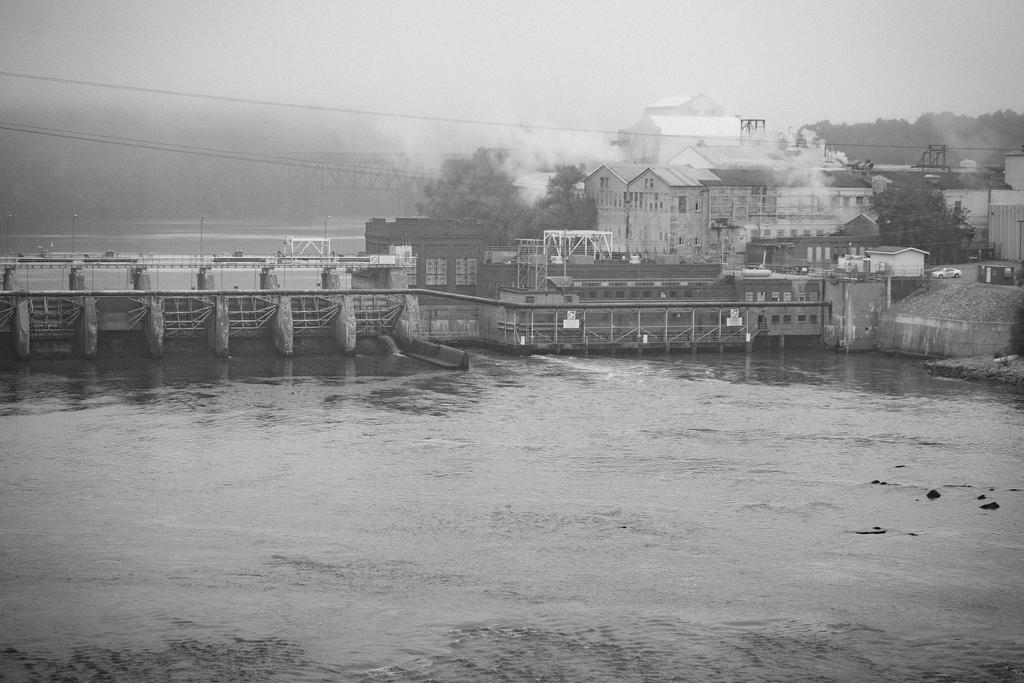What is the primary element visible in the image? There is water in the image. What type of structures can be seen in the image? There are buildings in the image. What connects the two sides of the water in the image? There is a bridge in the image. What type of vegetation is present in the image? There are trees in the image. What is the condition of the sky in the image? The sky is cloudy in the image. Is there any visible indication of human activity in the image? Yes, there is smoke in the image, which may indicate human activity. Where is the lettuce growing in the image? There is no lettuce present in the image. What type of hen can be seen on the bridge in the image? There is no hen present in the image, and the bridge is not mentioned as a location for any animals. 